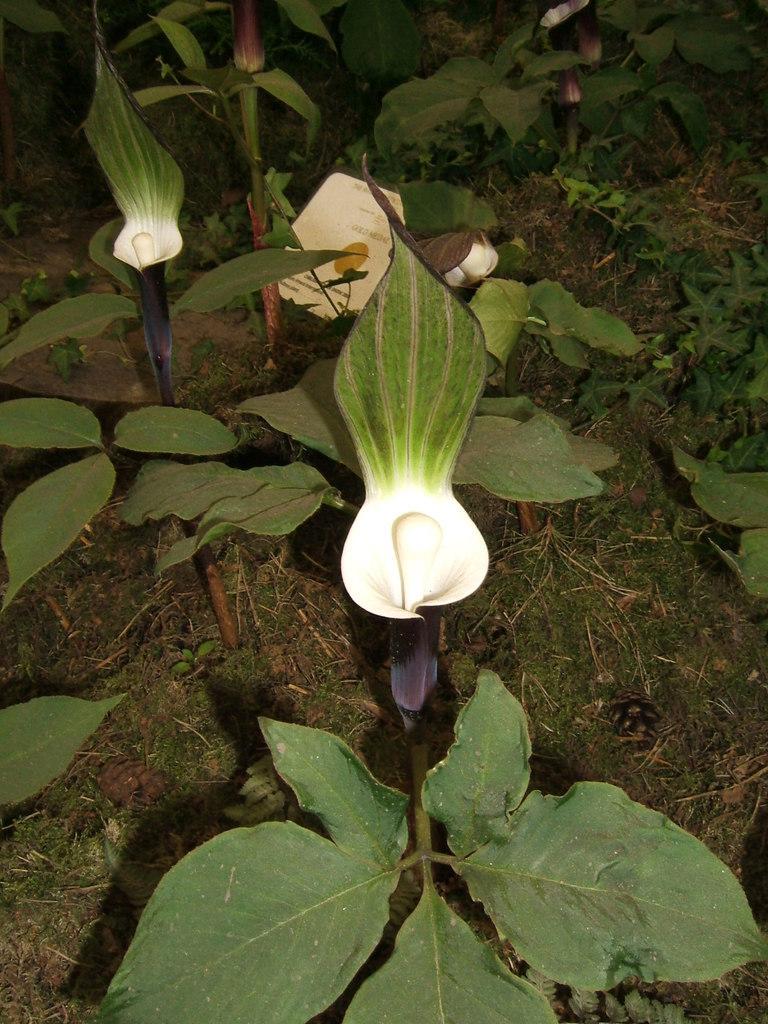Could you give a brief overview of what you see in this image? In this picture I can see there are small plants on the floor and it has some green and violet color flowers and there is soil and grass. 